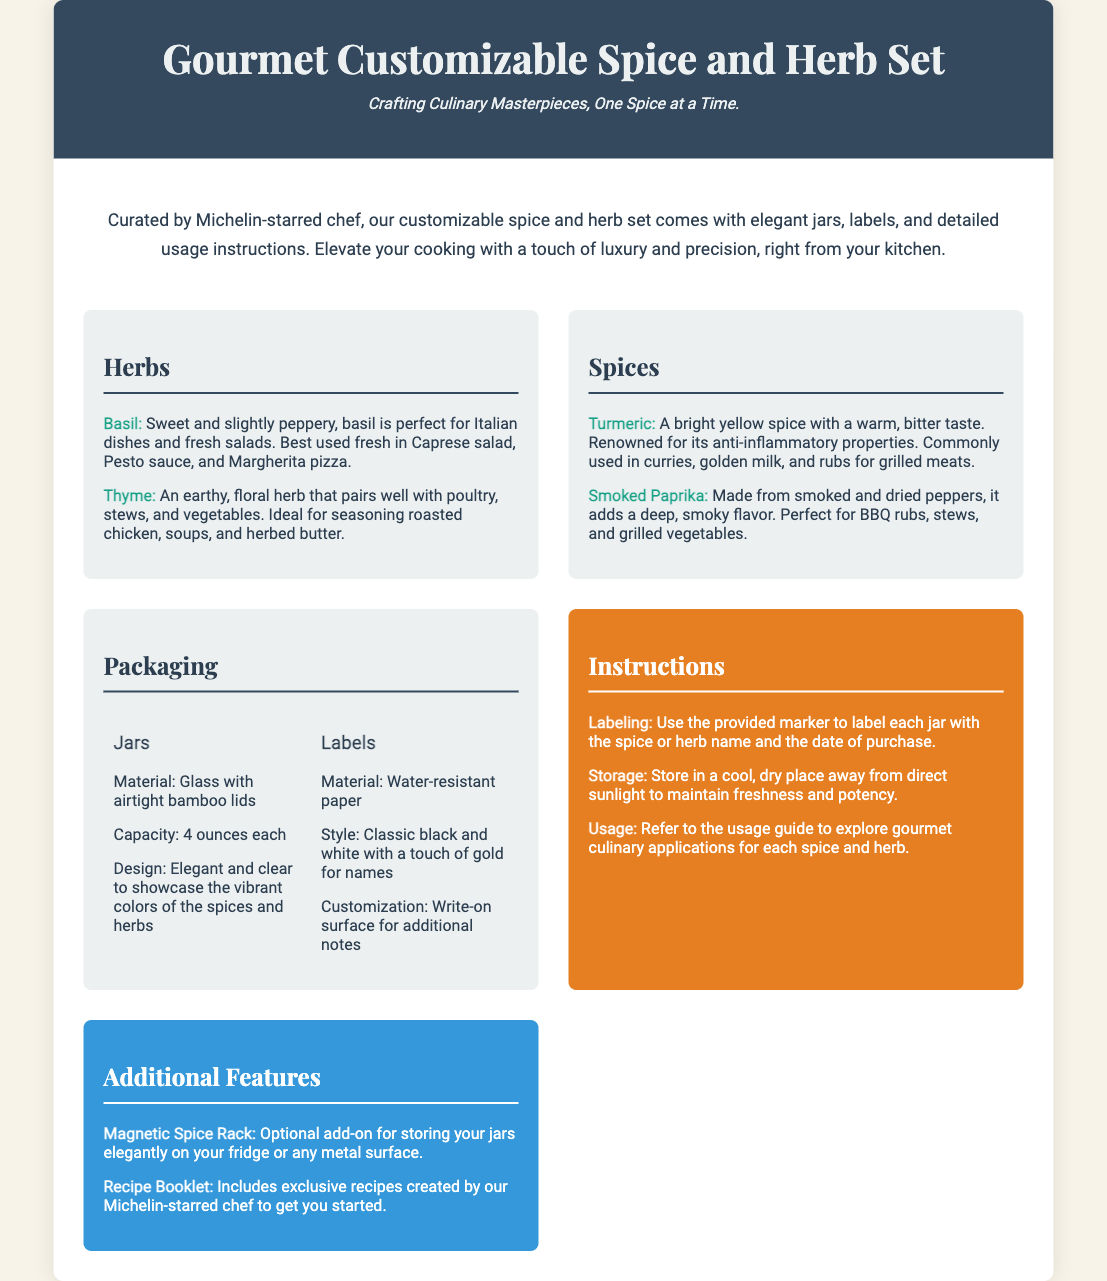what is the capacity of each jar? The capacity of each jar is mentioned in the packaging details section.
Answer: 4 ounces each who curated the spice and herb set? The description states that the set is curated by a Michelin-starred chef.
Answer: Michelin-starred chef what type of paper are the labels made of? The packaging details specify the material used for the labels.
Answer: Water-resistant paper what is one herb included in the set? The herbs section lists several herbs; one of them can be identified.
Answer: Basil what is the optional add-on for storing jars? The additional features section discusses a specific optional add-on.
Answer: Magnetic Spice Rack which spice is known for its anti-inflammatory properties? The spices section highlights a particular spice with notable health benefits.
Answer: Turmeric what does the instructions section recommend for storage? The instructions provide guidance on storage to maintain freshness.
Answer: Cool, dry place away from direct sunlight how are the jars described in terms of design? The packaging details mention the design aspects of the jars.
Answer: Elegant and clear to showcase the vibrant colors what exclusive content is included with the set? The additional features section mentions exclusive recipes as part of the offering.
Answer: Recipe Booklet 